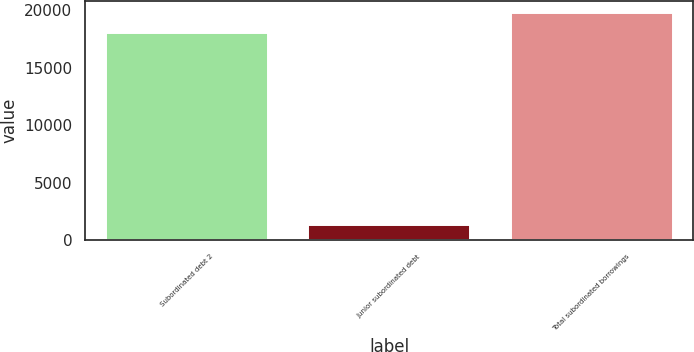<chart> <loc_0><loc_0><loc_500><loc_500><bar_chart><fcel>Subordinated debt 2<fcel>Junior subordinated debt<fcel>Total subordinated borrowings<nl><fcel>18004<fcel>1359<fcel>19804.4<nl></chart> 